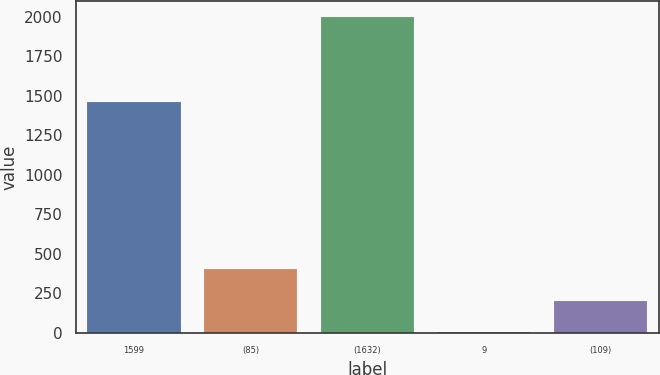Convert chart. <chart><loc_0><loc_0><loc_500><loc_500><bar_chart><fcel>1599<fcel>(85)<fcel>(1632)<fcel>9<fcel>(109)<nl><fcel>1460<fcel>401.4<fcel>1999<fcel>2<fcel>201.7<nl></chart> 